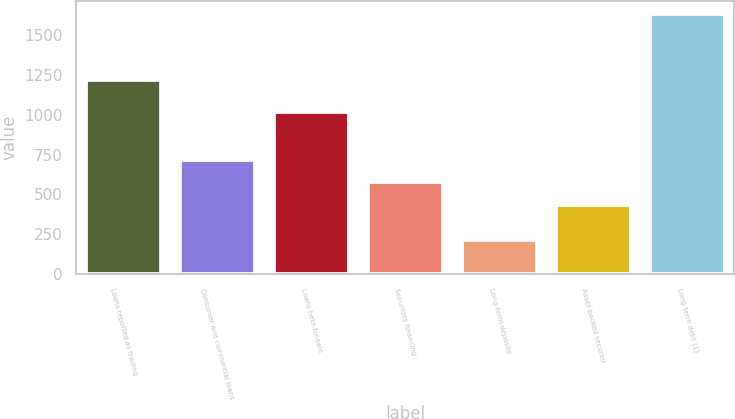Convert chart. <chart><loc_0><loc_0><loc_500><loc_500><bar_chart><fcel>Loans reported as trading<fcel>Consumer and commercial loans<fcel>Loans held-for-sale<fcel>Securities financing<fcel>Long-term deposits<fcel>Asset-backed secured<fcel>Long-term debt (1)<nl><fcel>1216<fcel>718<fcel>1017<fcel>576.5<fcel>216<fcel>435<fcel>1631<nl></chart> 